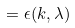<formula> <loc_0><loc_0><loc_500><loc_500>= \epsilon ( k , \lambda )</formula> 